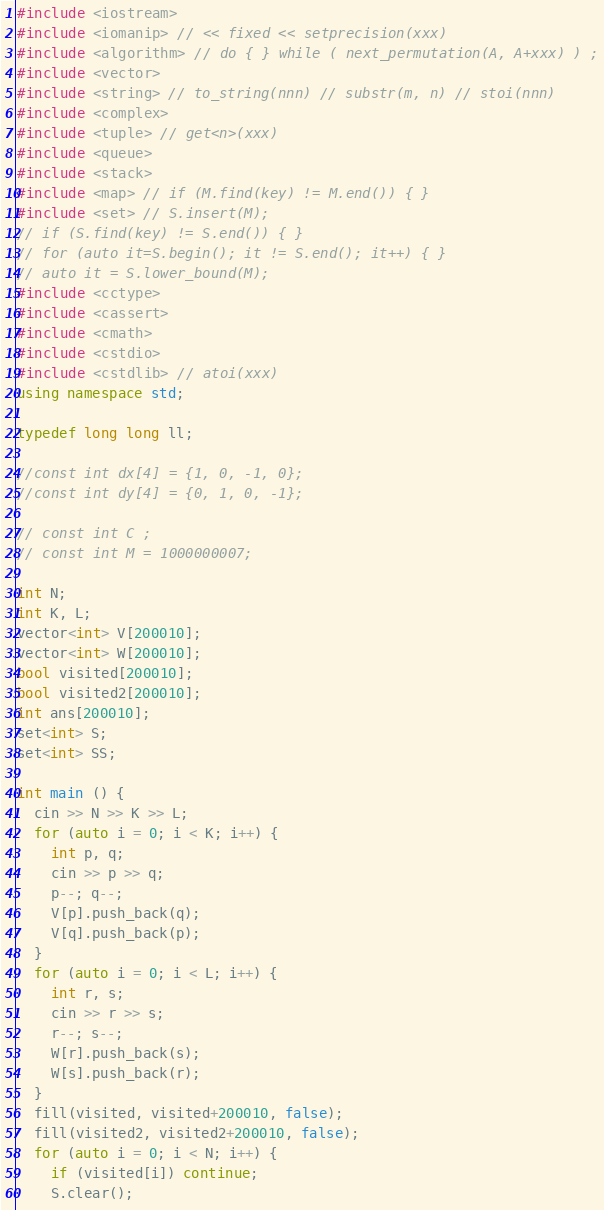<code> <loc_0><loc_0><loc_500><loc_500><_C++_>#include <iostream>
#include <iomanip> // << fixed << setprecision(xxx)
#include <algorithm> // do { } while ( next_permutation(A, A+xxx) ) ;
#include <vector>
#include <string> // to_string(nnn) // substr(m, n) // stoi(nnn)
#include <complex>
#include <tuple> // get<n>(xxx)
#include <queue>
#include <stack>
#include <map> // if (M.find(key) != M.end()) { }
#include <set> // S.insert(M);
// if (S.find(key) != S.end()) { }
// for (auto it=S.begin(); it != S.end(); it++) { }
// auto it = S.lower_bound(M);
#include <cctype>
#include <cassert>
#include <cmath>
#include <cstdio>
#include <cstdlib> // atoi(xxx)
using namespace std;

typedef long long ll;

//const int dx[4] = {1, 0, -1, 0};
//const int dy[4] = {0, 1, 0, -1};

// const int C ;
// const int M = 1000000007;

int N;
int K, L;
vector<int> V[200010];
vector<int> W[200010];
bool visited[200010];
bool visited2[200010];
int ans[200010];
set<int> S;
set<int> SS;

int main () {
  cin >> N >> K >> L;
  for (auto i = 0; i < K; i++) {
    int p, q;
    cin >> p >> q;
    p--; q--;
    V[p].push_back(q);
    V[q].push_back(p);
  }
  for (auto i = 0; i < L; i++) {
    int r, s;
    cin >> r >> s;
    r--; s--;
    W[r].push_back(s);
    W[s].push_back(r);
  }
  fill(visited, visited+200010, false);
  fill(visited2, visited2+200010, false);
  for (auto i = 0; i < N; i++) {
    if (visited[i]) continue;
    S.clear();</code> 